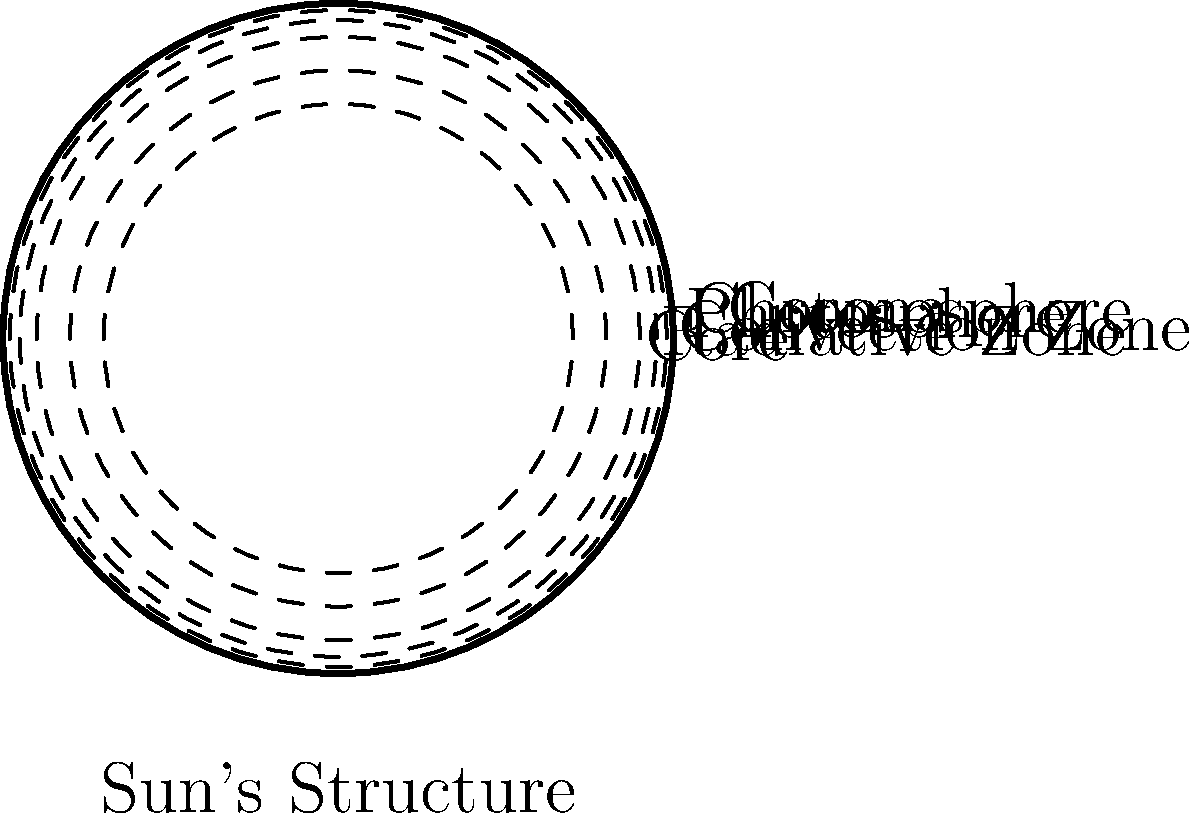As you gaze at the night sky during your overseas deployment, you recall the Sun's intricate structure. Which layer of the Sun is responsible for energy transport primarily through radiation and spans about 70% of the Sun's radius? To answer this question, let's break down the Sun's structure from the inside out:

1. Core: The innermost layer where nuclear fusion occurs, extending to about 25% of the Sun's radius.

2. Radiative Zone: This is the layer we're looking for. It extends from the edge of the core to about 70% of the Sun's radius. In this zone, energy is primarily transported through radiation.

3. Convection Zone: The outer layer of the Sun's interior, where energy is transported through convection currents.

4. Photosphere: The visible surface of the Sun.

5. Chromosphere: A thin layer above the photosphere.

6. Corona: The outermost layer of the Sun's atmosphere.

The Radiative Zone is characterized by:
- Its location between the core and the convection zone
- Energy transport primarily through radiation
- Spanning approximately 45% of the Sun's radius (from 25% to 70%)

This layer is crucial for understanding how energy generated in the core eventually reaches the Sun's surface.
Answer: Radiative Zone 